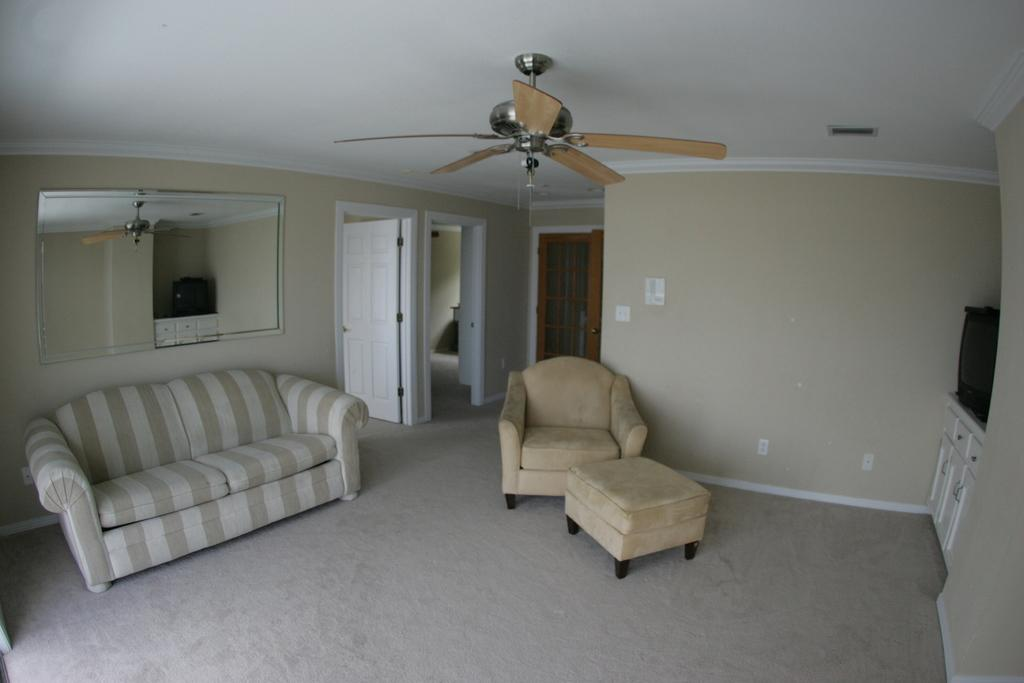What type of furniture is present in the image? There are sofas in the image. What appliance can be seen in the image? There is a fan in the image. What architectural feature is visible in the image? There is a door in the image. What structural element is present in the image? There is a wall in the image. How does the knee adjust the temperature in the image? There is no knee present in the image, and therefore no such adjustment can be observed. 